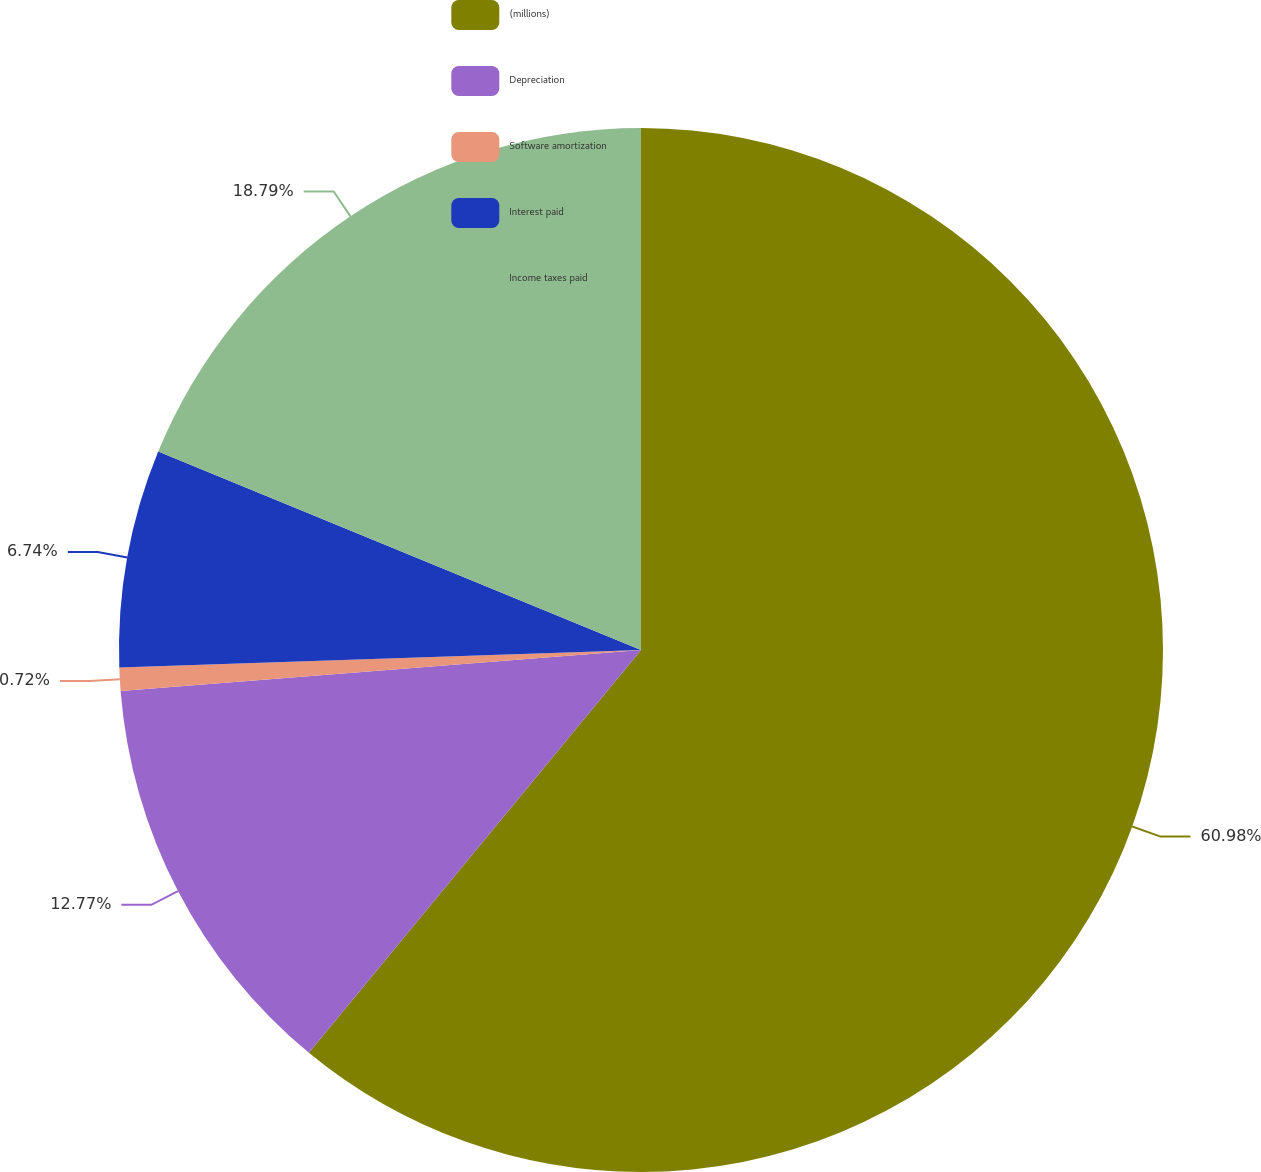<chart> <loc_0><loc_0><loc_500><loc_500><pie_chart><fcel>(millions)<fcel>Depreciation<fcel>Software amortization<fcel>Interest paid<fcel>Income taxes paid<nl><fcel>60.97%<fcel>12.77%<fcel>0.72%<fcel>6.74%<fcel>18.79%<nl></chart> 